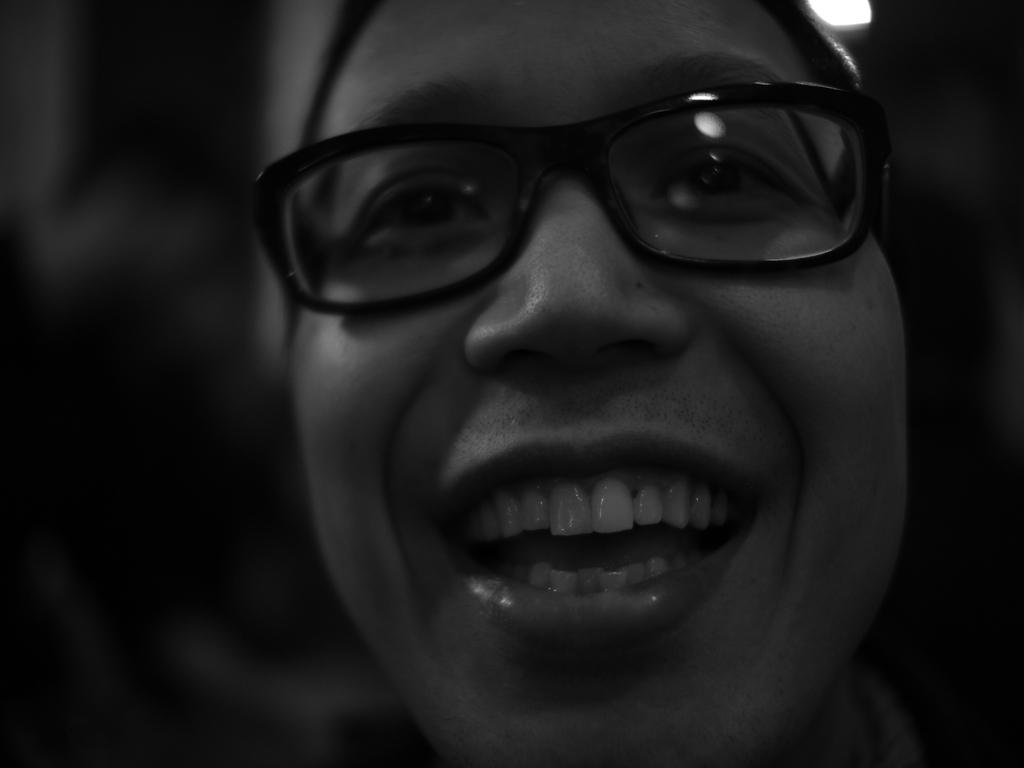What is the color scheme of the image? The image is black and white. What is the main subject of the image? There is a face of a person in the image. What color is the background of the image? The background of the image is black. What is the person in the image discussing with their friend? There is no indication of a discussion or a friend in the image, as it only features a black and white face of a person against a black background. 